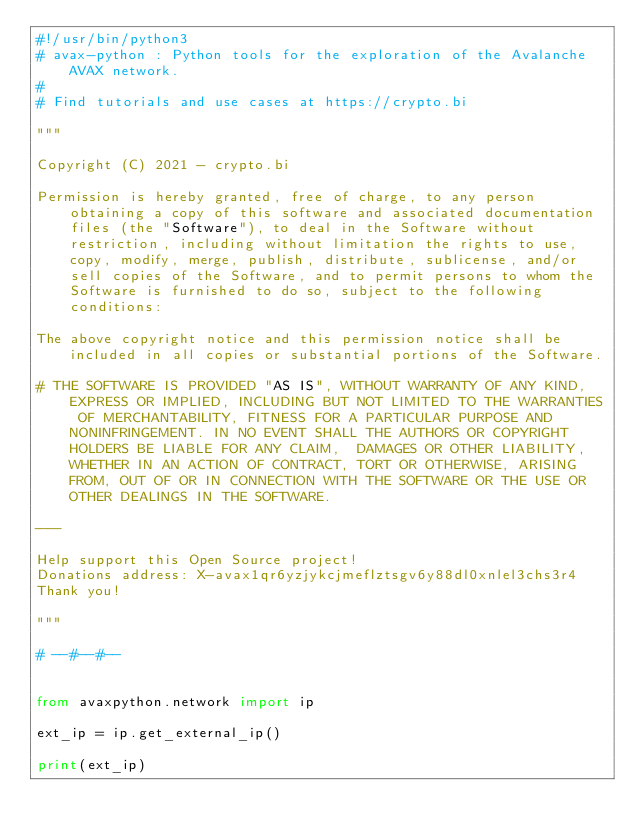Convert code to text. <code><loc_0><loc_0><loc_500><loc_500><_Python_>#!/usr/bin/python3
# avax-python : Python tools for the exploration of the Avalanche AVAX network.
#
# Find tutorials and use cases at https://crypto.bi

"""

Copyright (C) 2021 - crypto.bi

Permission is hereby granted, free of charge, to any person obtaining a copy of this software and associated documentation files (the "Software"), to deal in the Software without restriction, including without limitation the rights to use, copy, modify, merge, publish, distribute, sublicense, and/or sell copies of the Software, and to permit persons to whom the Software is furnished to do so, subject to the following conditions:

The above copyright notice and this permission notice shall be included in all copies or substantial portions of the Software.

# THE SOFTWARE IS PROVIDED "AS IS", WITHOUT WARRANTY OF ANY KIND, EXPRESS OR IMPLIED, INCLUDING BUT NOT LIMITED TO THE WARRANTIES OF MERCHANTABILITY, FITNESS FOR A PARTICULAR PURPOSE AND NONINFRINGEMENT. IN NO EVENT SHALL THE AUTHORS OR COPYRIGHT HOLDERS BE LIABLE FOR ANY CLAIM,  DAMAGES OR OTHER LIABILITY, WHETHER IN AN ACTION OF CONTRACT, TORT OR OTHERWISE, ARISING FROM, OUT OF OR IN CONNECTION WITH THE SOFTWARE OR THE USE OR OTHER DEALINGS IN THE SOFTWARE.

---

Help support this Open Source project!
Donations address: X-avax1qr6yzjykcjmeflztsgv6y88dl0xnlel3chs3r4
Thank you!

"""

# --#--#--


from avaxpython.network import ip

ext_ip = ip.get_external_ip()

print(ext_ip)
</code> 